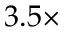Convert formula to latex. <formula><loc_0><loc_0><loc_500><loc_500>3 . 5 \times</formula> 